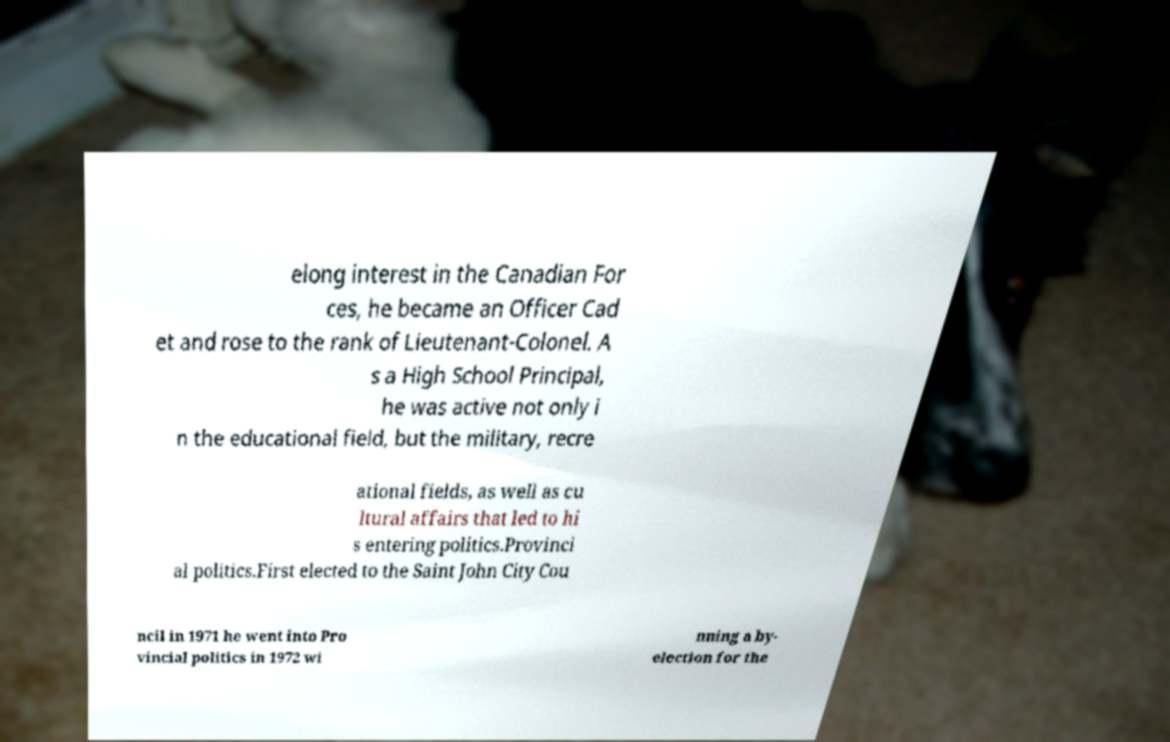For documentation purposes, I need the text within this image transcribed. Could you provide that? elong interest in the Canadian For ces, he became an Officer Cad et and rose to the rank of Lieutenant-Colonel. A s a High School Principal, he was active not only i n the educational field, but the military, recre ational fields, as well as cu ltural affairs that led to hi s entering politics.Provinci al politics.First elected to the Saint John City Cou ncil in 1971 he went into Pro vincial politics in 1972 wi nning a by- election for the 